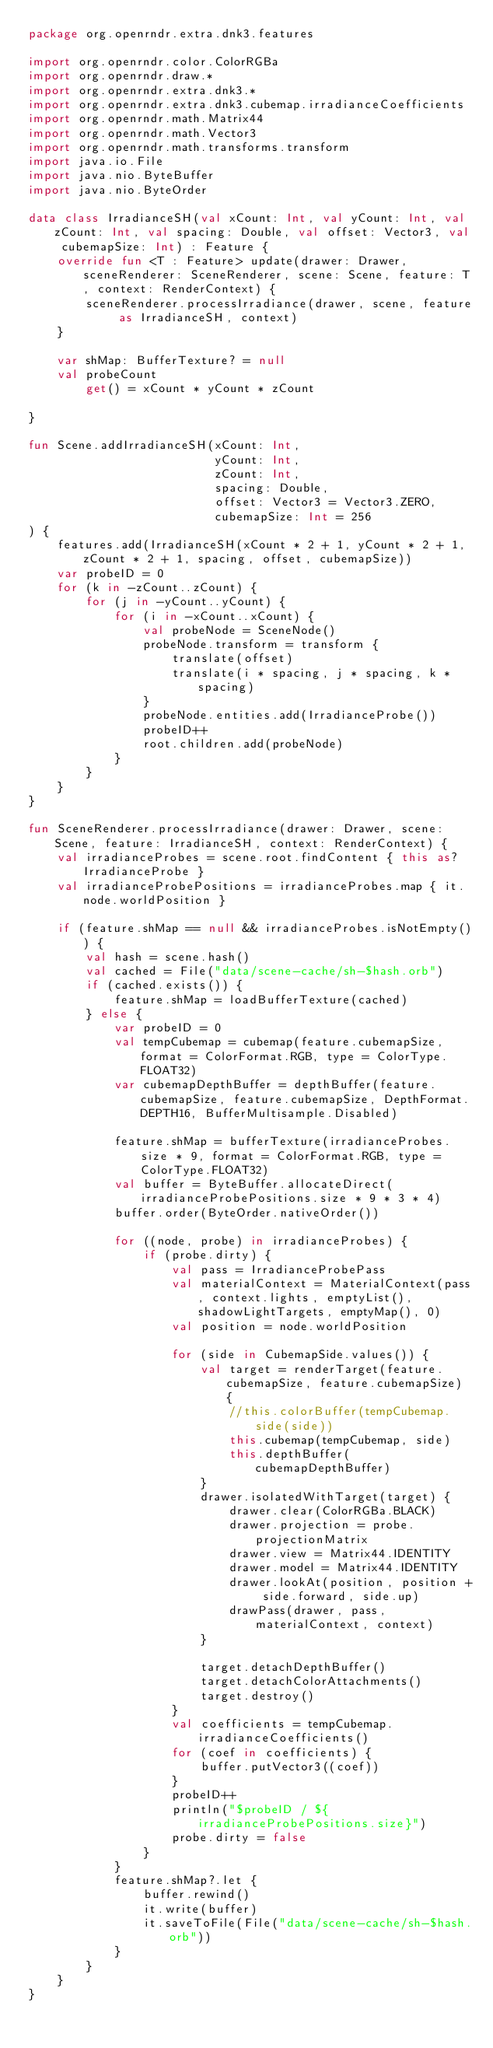<code> <loc_0><loc_0><loc_500><loc_500><_Kotlin_>package org.openrndr.extra.dnk3.features

import org.openrndr.color.ColorRGBa
import org.openrndr.draw.*
import org.openrndr.extra.dnk3.*
import org.openrndr.extra.dnk3.cubemap.irradianceCoefficients
import org.openrndr.math.Matrix44
import org.openrndr.math.Vector3
import org.openrndr.math.transforms.transform
import java.io.File
import java.nio.ByteBuffer
import java.nio.ByteOrder

data class IrradianceSH(val xCount: Int, val yCount: Int, val zCount: Int, val spacing: Double, val offset: Vector3, val cubemapSize: Int) : Feature {
    override fun <T : Feature> update(drawer: Drawer, sceneRenderer: SceneRenderer, scene: Scene, feature: T, context: RenderContext) {
        sceneRenderer.processIrradiance(drawer, scene, feature as IrradianceSH, context)
    }

    var shMap: BufferTexture? = null
    val probeCount
        get() = xCount * yCount * zCount

}

fun Scene.addIrradianceSH(xCount: Int,
                          yCount: Int,
                          zCount: Int,
                          spacing: Double,
                          offset: Vector3 = Vector3.ZERO,
                          cubemapSize: Int = 256
) {
    features.add(IrradianceSH(xCount * 2 + 1, yCount * 2 + 1, zCount * 2 + 1, spacing, offset, cubemapSize))
    var probeID = 0
    for (k in -zCount..zCount) {
        for (j in -yCount..yCount) {
            for (i in -xCount..xCount) {
                val probeNode = SceneNode()
                probeNode.transform = transform {
                    translate(offset)
                    translate(i * spacing, j * spacing, k * spacing)
                }
                probeNode.entities.add(IrradianceProbe())
                probeID++
                root.children.add(probeNode)
            }
        }
    }
}

fun SceneRenderer.processIrradiance(drawer: Drawer, scene: Scene, feature: IrradianceSH, context: RenderContext) {
    val irradianceProbes = scene.root.findContent { this as? IrradianceProbe }
    val irradianceProbePositions = irradianceProbes.map { it.node.worldPosition }

    if (feature.shMap == null && irradianceProbes.isNotEmpty()) {
        val hash = scene.hash()
        val cached = File("data/scene-cache/sh-$hash.orb")
        if (cached.exists()) {
            feature.shMap = loadBufferTexture(cached)
        } else {
            var probeID = 0
            val tempCubemap = cubemap(feature.cubemapSize, format = ColorFormat.RGB, type = ColorType.FLOAT32)
            var cubemapDepthBuffer = depthBuffer(feature.cubemapSize, feature.cubemapSize, DepthFormat.DEPTH16, BufferMultisample.Disabled)

            feature.shMap = bufferTexture(irradianceProbes.size * 9, format = ColorFormat.RGB, type = ColorType.FLOAT32)
            val buffer = ByteBuffer.allocateDirect(irradianceProbePositions.size * 9 * 3 * 4)
            buffer.order(ByteOrder.nativeOrder())

            for ((node, probe) in irradianceProbes) {
                if (probe.dirty) {
                    val pass = IrradianceProbePass
                    val materialContext = MaterialContext(pass, context.lights, emptyList(), shadowLightTargets, emptyMap(), 0)
                    val position = node.worldPosition

                    for (side in CubemapSide.values()) {
                        val target = renderTarget(feature.cubemapSize, feature.cubemapSize) {
                            //this.colorBuffer(tempCubemap.side(side))
                            this.cubemap(tempCubemap, side)
                            this.depthBuffer(cubemapDepthBuffer)
                        }
                        drawer.isolatedWithTarget(target) {
                            drawer.clear(ColorRGBa.BLACK)
                            drawer.projection = probe.projectionMatrix
                            drawer.view = Matrix44.IDENTITY
                            drawer.model = Matrix44.IDENTITY
                            drawer.lookAt(position, position + side.forward, side.up)
                            drawPass(drawer, pass, materialContext, context)
                        }

                        target.detachDepthBuffer()
                        target.detachColorAttachments()
                        target.destroy()
                    }
                    val coefficients = tempCubemap.irradianceCoefficients()
                    for (coef in coefficients) {
                        buffer.putVector3((coef))
                    }
                    probeID++
                    println("$probeID / ${irradianceProbePositions.size}")
                    probe.dirty = false
                }
            }
            feature.shMap?.let {
                buffer.rewind()
                it.write(buffer)
                it.saveToFile(File("data/scene-cache/sh-$hash.orb"))
            }
        }
    }
}
</code> 